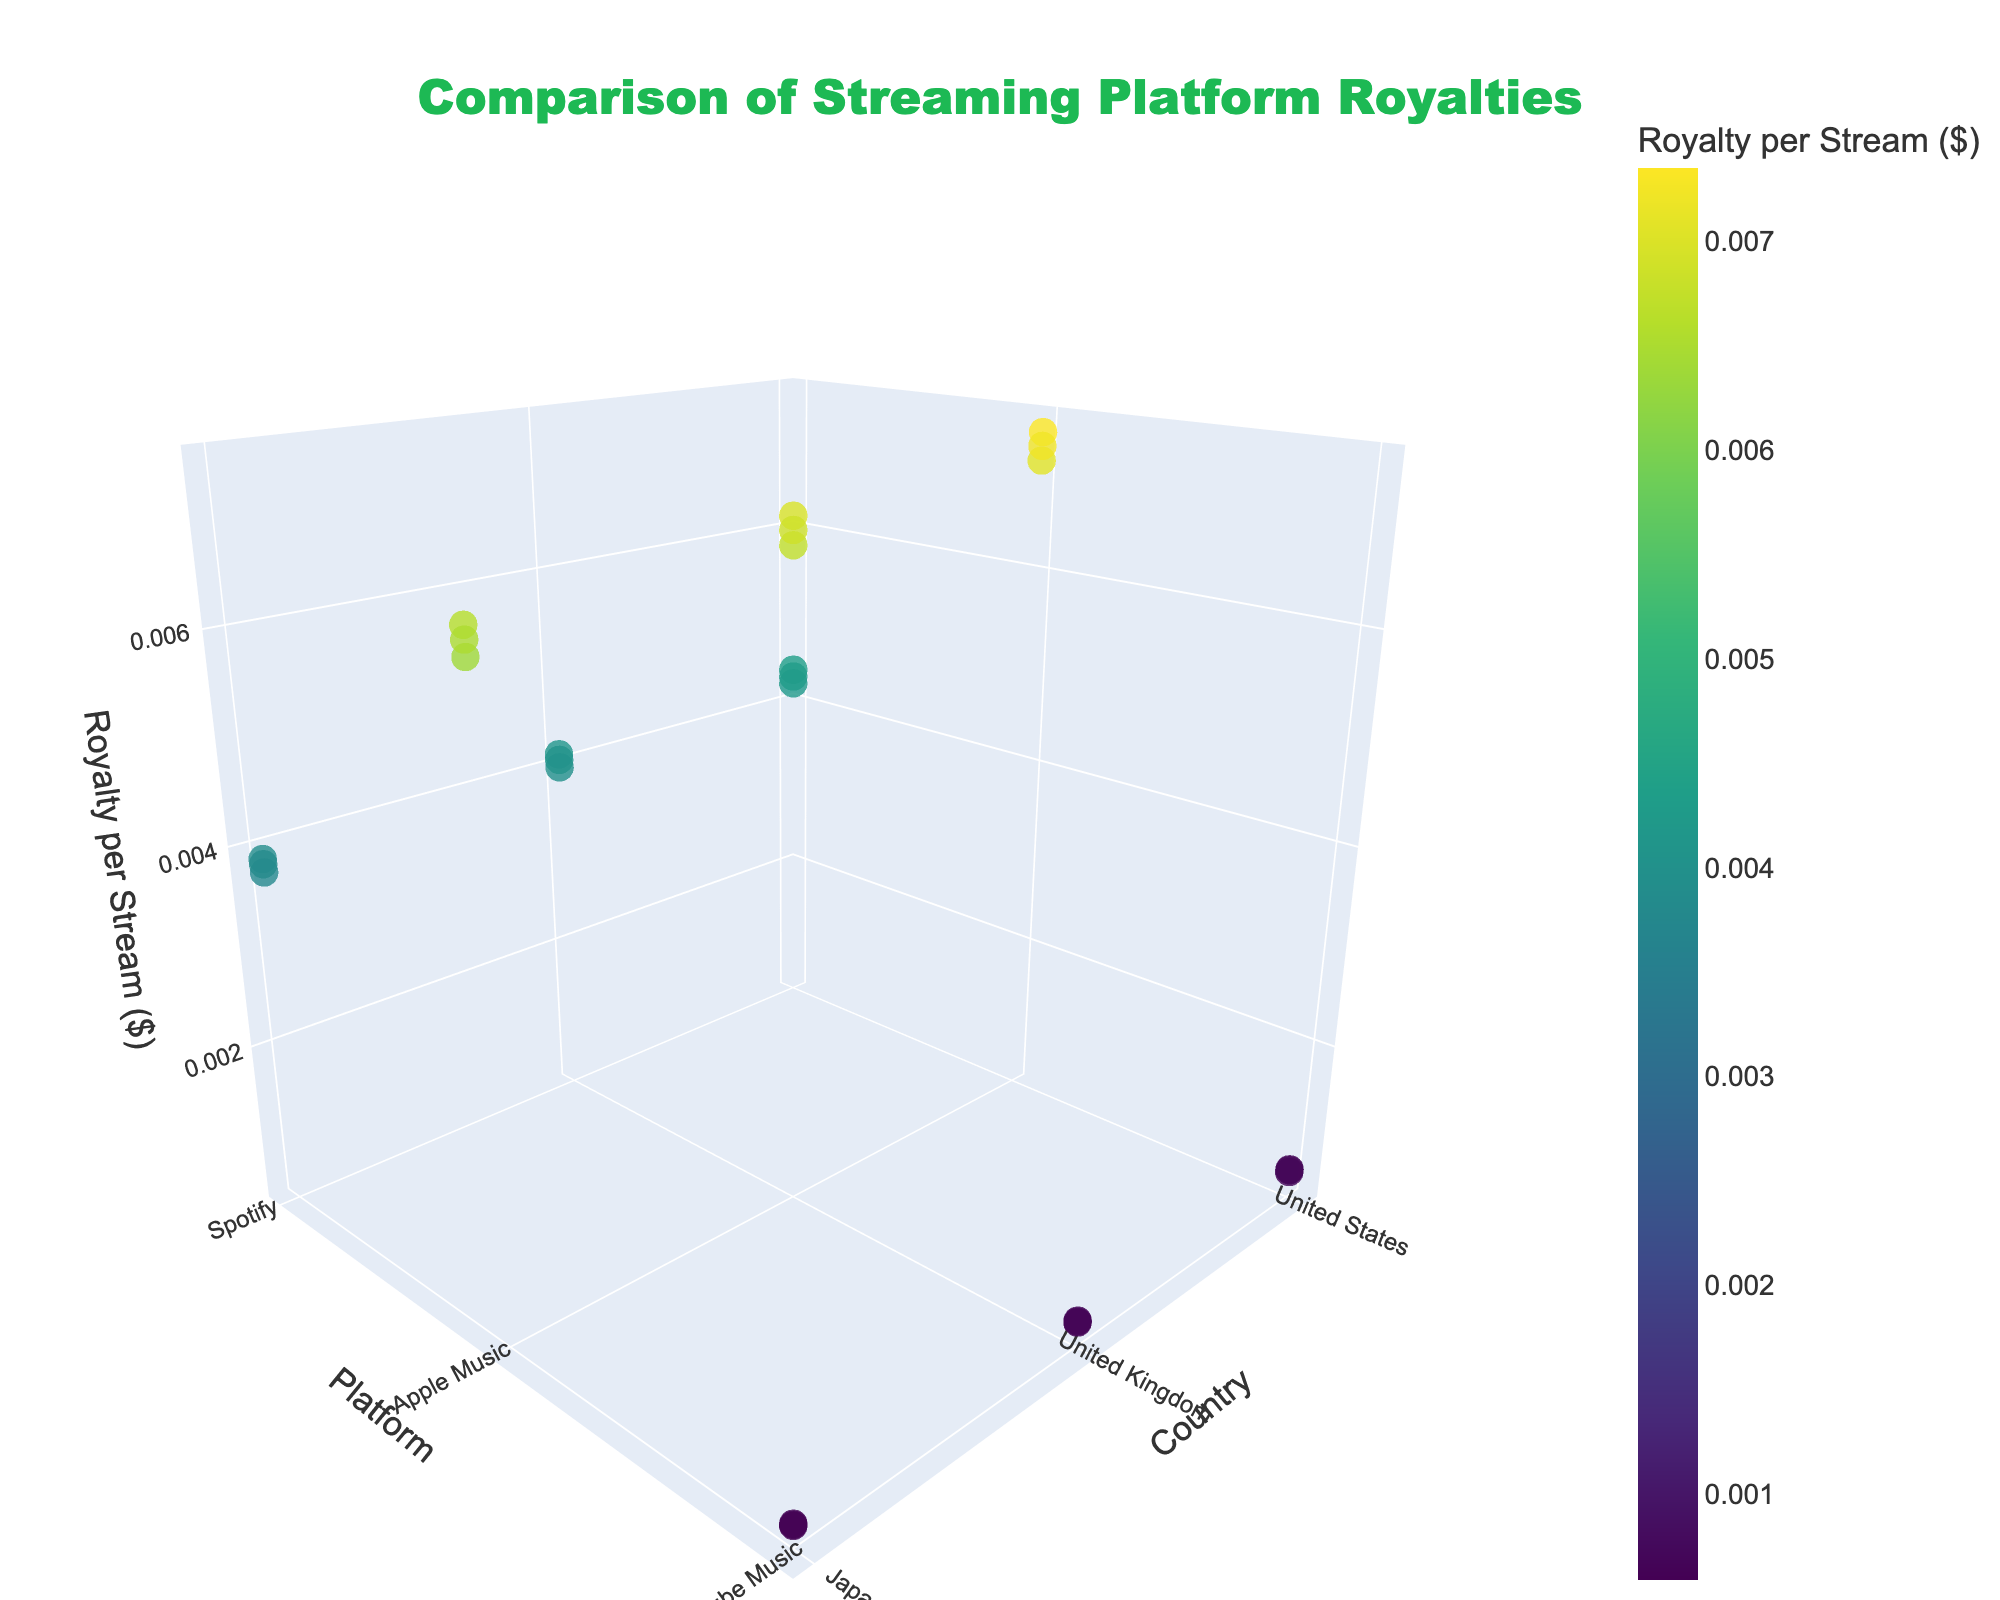What are the three platforms shown in the plot? The plot includes a color bar for "Royalty per Stream ($)" and markers distributed among three platforms apparent in the 'Platform' axis: Spotify, Apple Music, and YouTube Music.
Answer: Spotify, Apple Music, YouTube Music Which country has the highest royalty per stream for Apple Music? By examining the 'Royalty per Stream ($)' axis for the Apple's data points and locating the highest one, which is closest to 0.00735, we can see that the United States has the highest royalty per stream for Apple Music.
Answer: United States Comparatively, which platform pays the lowest royalties per stream across all genres and countries? Observing the 'Royalty per Stream' axis, the smallest values (~0.00059 to ~0.00069) are for YouTube Music, indicating it pays the lowest royalties per stream compared to Spotify and Apple Music.
Answer: YouTube Music How does the royalty per stream for Spotify in the United Kingdom compare for Rock and Alternative genres? Looking at the 'Country' axis for the United Kingdom and identifying Spotify data points, the 'Royalty per Stream' for Rock is about 0.00412 while for Alternative it's approximately 0.00406. Rock slightly outperforms Alternative in terms of royalties in the UK for Spotify.
Answer: Rock is higher What's the average royalty per stream for Apple Music across all genres in Japan? To find this, identify Apple Music data points in Japan along the 'Country' axis. For Rock (0.00662), Electronic (0.00638), and Alternative (0.00651), sum these values and divide by 3. (0.00662 + 0.00638 + 0.00651) / 3 = 0.00650
Answer: 0.00650 What is the relationship between country and royalty per stream for YouTube Music? Through the 'Country' and 'Royalty per Stream' axes, it is evident that the royalties for YouTube Music are consistently low in all countries, with slight variations, showing uniformity but at a lesser value.
Answer: Consistently low Which genre in the United States has the highest average royalties across all platforms? Identify the United States and examine all genres for each platform (Spotify, Apple Music, YouTube Music), compute their averages. Rock: (0.00437 + 0.00735 + 0.00069) / 3 = 0.00480, Electronic: (0.00421 + 0.00708 + 0.00066) / 3 = 0.00465, Alternative: (0.00429 + 0.00722 + 0.00068) / 3 = 0.00473. Rock has the highest average.
Answer: Rock What color scale is used in the plot to represent 'Royalty per Stream'? The color of the markers in the plot corresponds to the 'Royalty per Stream' value using the Viridis color scale as mentioned in the marker specifications.
Answer: Viridis 